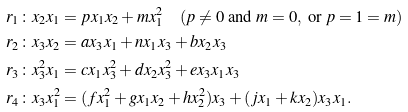Convert formula to latex. <formula><loc_0><loc_0><loc_500><loc_500>r _ { 1 } \colon x _ { 2 } x _ { 1 } & = p x _ { 1 } x _ { 2 } + m x _ { 1 } ^ { 2 } \quad ( p \neq 0 \ \text {and} \ m = 0 , \ \text {or} \ p = 1 = m ) \\ r _ { 2 } \colon x _ { 3 } x _ { 2 } & = a x _ { 3 } x _ { 1 } + n x _ { 1 } x _ { 3 } + b x _ { 2 } x _ { 3 } \\ r _ { 3 } \colon x _ { 3 } ^ { 2 } x _ { 1 } & = c x _ { 1 } x _ { 3 } ^ { 2 } + d x _ { 2 } x _ { 3 } ^ { 2 } + e x _ { 3 } x _ { 1 } x _ { 3 } \\ r _ { 4 } \colon x _ { 3 } x _ { 1 } ^ { 2 } & = ( f x _ { 1 } ^ { 2 } + g x _ { 1 } x _ { 2 } + h x _ { 2 } ^ { 2 } ) x _ { 3 } + ( j x _ { 1 } + k x _ { 2 } ) x _ { 3 } x _ { 1 } .</formula> 